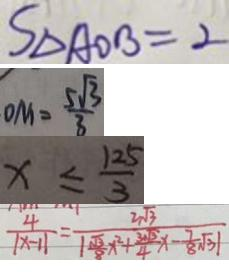<formula> <loc_0><loc_0><loc_500><loc_500>S _ { \Delta A O B } = 2 
 D M = \frac { 5 \sqrt { 3 } } { 3 } 
 x \leq \frac { 1 2 5 } { 3 } 
 \frac { 4 } { \vert x - 1 \vert } = \frac { 2 \sqrt { 3 } } { \vert \frac { \sqrt { 3 } } { 8 } x ^ { 2 } + \frac { 3 \sqrt { 3 } } { 4 } x - \frac { 7 } { 8 } \sqrt { 3 } \vert }</formula> 